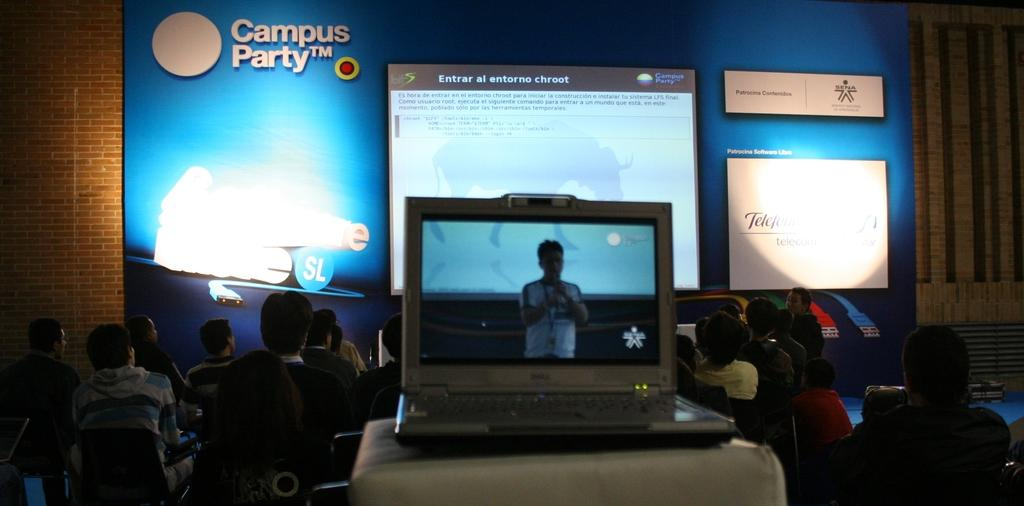<image>
Summarize the visual content of the image. A laptop sits recording a presentation at the Campus Party conference. 